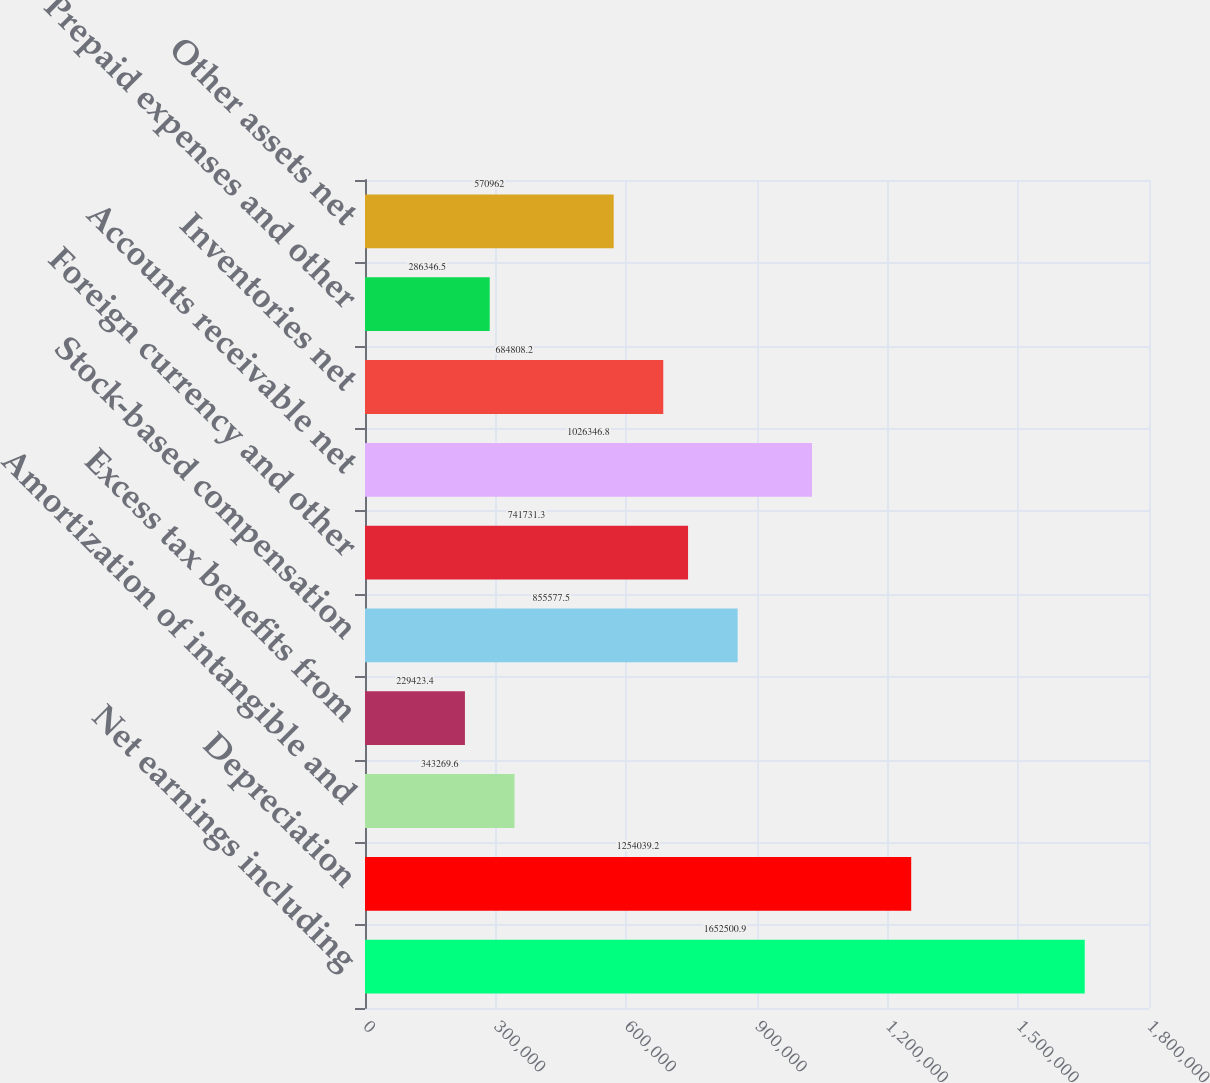Convert chart. <chart><loc_0><loc_0><loc_500><loc_500><bar_chart><fcel>Net earnings including<fcel>Depreciation<fcel>Amortization of intangible and<fcel>Excess tax benefits from<fcel>Stock-based compensation<fcel>Foreign currency and other<fcel>Accounts receivable net<fcel>Inventories net<fcel>Prepaid expenses and other<fcel>Other assets net<nl><fcel>1.6525e+06<fcel>1.25404e+06<fcel>343270<fcel>229423<fcel>855578<fcel>741731<fcel>1.02635e+06<fcel>684808<fcel>286346<fcel>570962<nl></chart> 